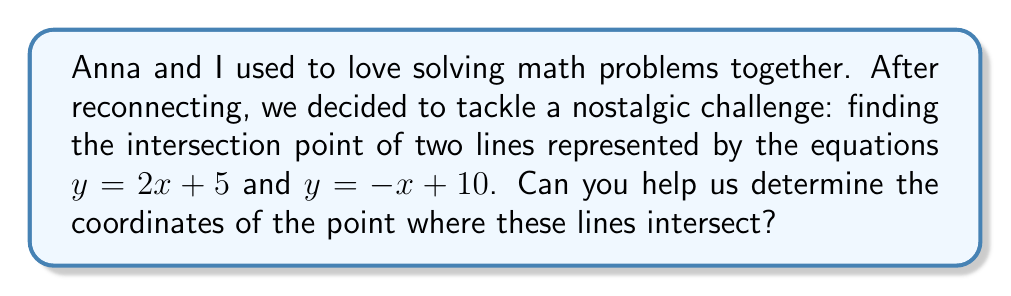Can you solve this math problem? To find the intersection point of two lines, we need to solve the system of linear equations:

$$\begin{cases}
y = 2x + 5 \\
y = -x + 10
\end{cases}$$

1) Since both equations are equal to y, we can set them equal to each other:

   $2x + 5 = -x + 10$

2) Add x to both sides:

   $3x + 5 = 10$

3) Subtract 5 from both sides:

   $3x = 5$

4) Divide both sides by 3:

   $x = \frac{5}{3}$

5) Now that we know x, we can substitute it into either of the original equations. Let's use $y = 2x + 5$:

   $y = 2(\frac{5}{3}) + 5$
   $y = \frac{10}{3} + 5$
   $y = \frac{10}{3} + \frac{15}{3}$
   $y = \frac{25}{3}$

6) Therefore, the intersection point is $(\frac{5}{3}, \frac{25}{3})$.
Answer: $(\frac{5}{3}, \frac{25}{3})$ 